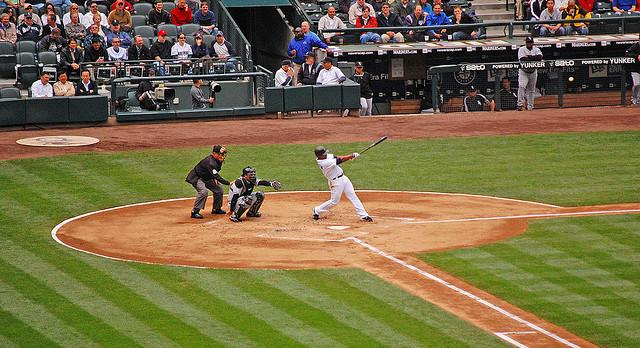Which wood used to make baseball bat? Please explain your reasoning. maple. The baseball bat used by the batter at the plate is made from maple which is a very strong wood. 